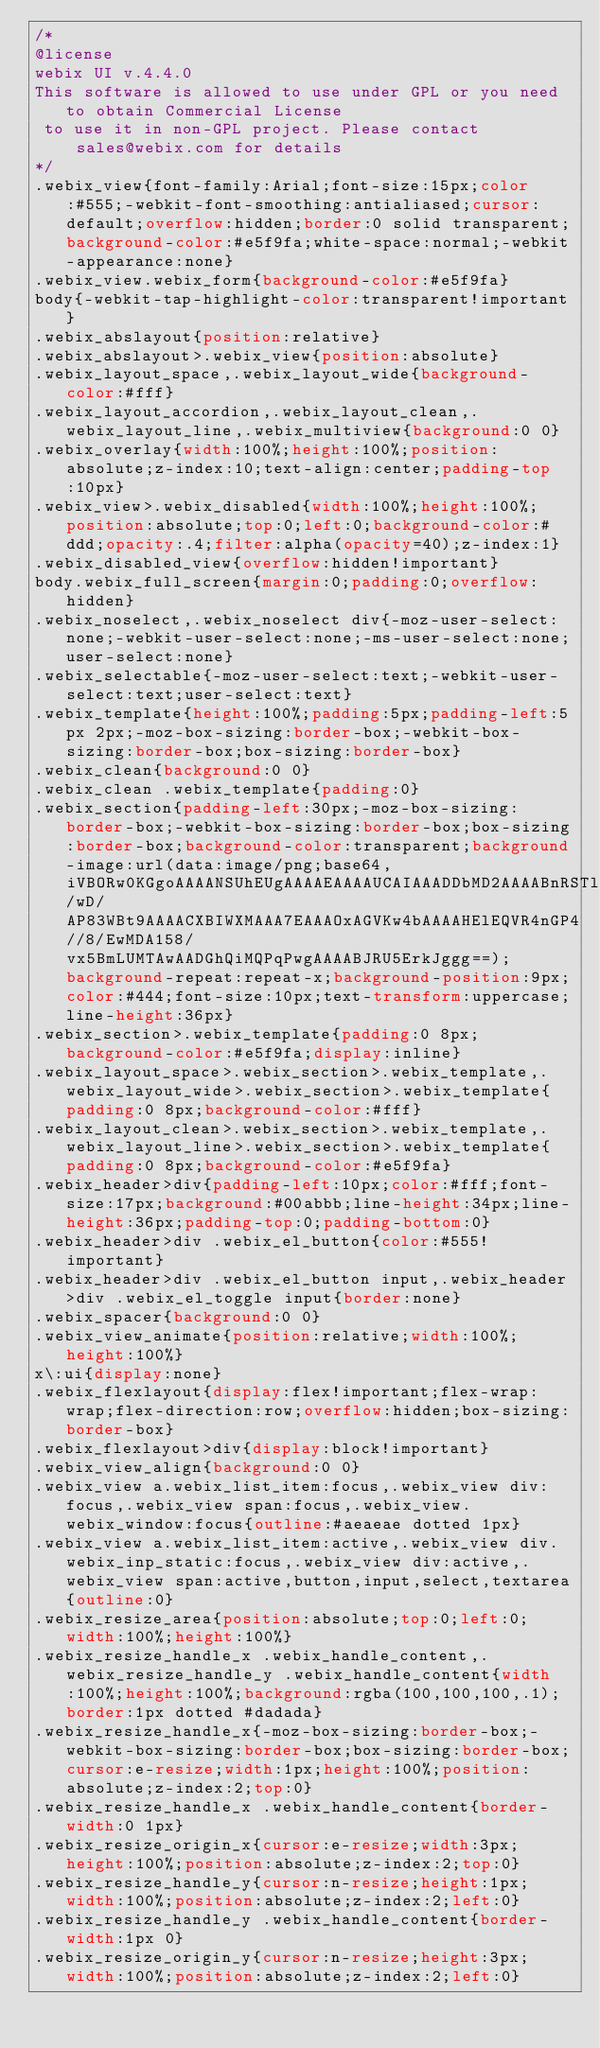<code> <loc_0><loc_0><loc_500><loc_500><_CSS_>/*
@license
webix UI v.4.4.0
This software is allowed to use under GPL or you need to obtain Commercial License 
 to use it in non-GPL project. Please contact sales@webix.com for details
*/
.webix_view{font-family:Arial;font-size:15px;color:#555;-webkit-font-smoothing:antialiased;cursor:default;overflow:hidden;border:0 solid transparent;background-color:#e5f9fa;white-space:normal;-webkit-appearance:none}
.webix_view.webix_form{background-color:#e5f9fa}
body{-webkit-tap-highlight-color:transparent!important}
.webix_abslayout{position:relative}
.webix_abslayout>.webix_view{position:absolute}
.webix_layout_space,.webix_layout_wide{background-color:#fff}
.webix_layout_accordion,.webix_layout_clean,.webix_layout_line,.webix_multiview{background:0 0}
.webix_overlay{width:100%;height:100%;position:absolute;z-index:10;text-align:center;padding-top:10px}
.webix_view>.webix_disabled{width:100%;height:100%;position:absolute;top:0;left:0;background-color:#ddd;opacity:.4;filter:alpha(opacity=40);z-index:1}
.webix_disabled_view{overflow:hidden!important}
body.webix_full_screen{margin:0;padding:0;overflow:hidden}
.webix_noselect,.webix_noselect div{-moz-user-select:none;-webkit-user-select:none;-ms-user-select:none;user-select:none}
.webix_selectable{-moz-user-select:text;-webkit-user-select:text;user-select:text}
.webix_template{height:100%;padding:5px;padding-left:5px 2px;-moz-box-sizing:border-box;-webkit-box-sizing:border-box;box-sizing:border-box}
.webix_clean{background:0 0}
.webix_clean .webix_template{padding:0}
.webix_section{padding-left:30px;-moz-box-sizing:border-box;-webkit-box-sizing:border-box;box-sizing:border-box;background-color:transparent;background-image:url(data:image/png;base64,iVBORw0KGgoAAAANSUhEUgAAAAEAAAAUCAIAAADDbMD2AAAABnRSTlMA/wD/AP83WBt9AAAACXBIWXMAAA7EAAAOxAGVKw4bAAAAHElEQVR4nGP4//8/EwMDA158/vx5BmLUMTAwAADGhQiMQPqPwgAAAABJRU5ErkJggg==);background-repeat:repeat-x;background-position:9px;color:#444;font-size:10px;text-transform:uppercase;line-height:36px}
.webix_section>.webix_template{padding:0 8px;background-color:#e5f9fa;display:inline}
.webix_layout_space>.webix_section>.webix_template,.webix_layout_wide>.webix_section>.webix_template{padding:0 8px;background-color:#fff}
.webix_layout_clean>.webix_section>.webix_template,.webix_layout_line>.webix_section>.webix_template{padding:0 8px;background-color:#e5f9fa}
.webix_header>div{padding-left:10px;color:#fff;font-size:17px;background:#00abbb;line-height:34px;line-height:36px;padding-top:0;padding-bottom:0}
.webix_header>div .webix_el_button{color:#555!important}
.webix_header>div .webix_el_button input,.webix_header>div .webix_el_toggle input{border:none}
.webix_spacer{background:0 0}
.webix_view_animate{position:relative;width:100%;height:100%}
x\:ui{display:none}
.webix_flexlayout{display:flex!important;flex-wrap:wrap;flex-direction:row;overflow:hidden;box-sizing:border-box}
.webix_flexlayout>div{display:block!important}
.webix_view_align{background:0 0}
.webix_view a.webix_list_item:focus,.webix_view div:focus,.webix_view span:focus,.webix_view.webix_window:focus{outline:#aeaeae dotted 1px}
.webix_view a.webix_list_item:active,.webix_view div.webix_inp_static:focus,.webix_view div:active,.webix_view span:active,button,input,select,textarea{outline:0}
.webix_resize_area{position:absolute;top:0;left:0;width:100%;height:100%}
.webix_resize_handle_x .webix_handle_content,.webix_resize_handle_y .webix_handle_content{width:100%;height:100%;background:rgba(100,100,100,.1);border:1px dotted #dadada}
.webix_resize_handle_x{-moz-box-sizing:border-box;-webkit-box-sizing:border-box;box-sizing:border-box;cursor:e-resize;width:1px;height:100%;position:absolute;z-index:2;top:0}
.webix_resize_handle_x .webix_handle_content{border-width:0 1px}
.webix_resize_origin_x{cursor:e-resize;width:3px;height:100%;position:absolute;z-index:2;top:0}
.webix_resize_handle_y{cursor:n-resize;height:1px;width:100%;position:absolute;z-index:2;left:0}
.webix_resize_handle_y .webix_handle_content{border-width:1px 0}
.webix_resize_origin_y{cursor:n-resize;height:3px;width:100%;position:absolute;z-index:2;left:0}</code> 